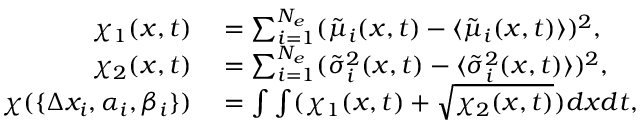Convert formula to latex. <formula><loc_0><loc_0><loc_500><loc_500>\begin{array} { r l } { \chi _ { 1 } ( x , t ) } & = \sum _ { i = 1 } ^ { N _ { e } } ( \tilde { \mu } _ { i } ( x , t ) - \langle { \tilde { \mu } _ { i } ( x , t ) } ) ^ { 2 } , } \\ { \chi _ { 2 } ( x , t ) } & = \sum _ { i = 1 } ^ { N _ { e } } ( \tilde { \sigma } _ { i } ^ { 2 } ( x , t ) - \langle { \tilde { \sigma } _ { i } ^ { 2 } ( x , t ) } ) ^ { 2 } , } \\ { \chi ( \{ \Delta x _ { i } , \alpha _ { i } , \beta _ { i } \} ) } & = \int \int ( \chi _ { 1 } ( x , t ) + \sqrt { \chi _ { 2 } ( x , t ) } ) d x d t , } \end{array}</formula> 